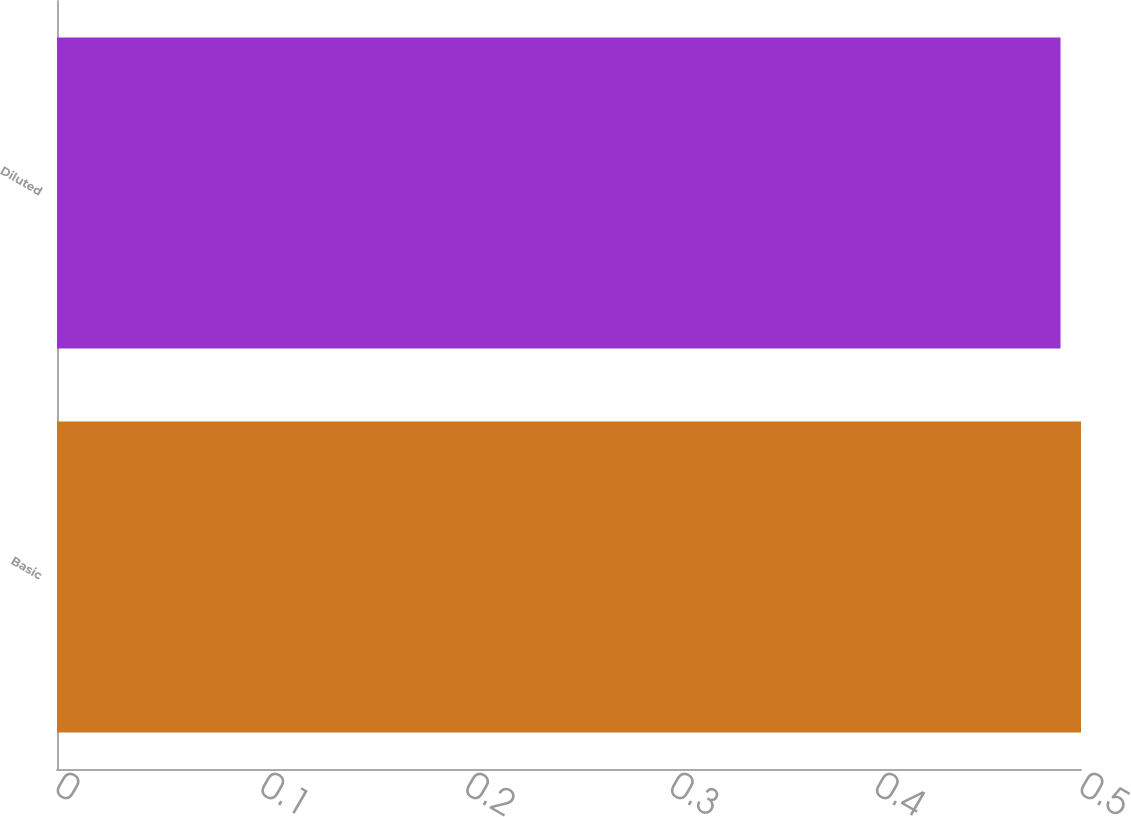Convert chart. <chart><loc_0><loc_0><loc_500><loc_500><bar_chart><fcel>Basic<fcel>Diluted<nl><fcel>0.5<fcel>0.49<nl></chart> 